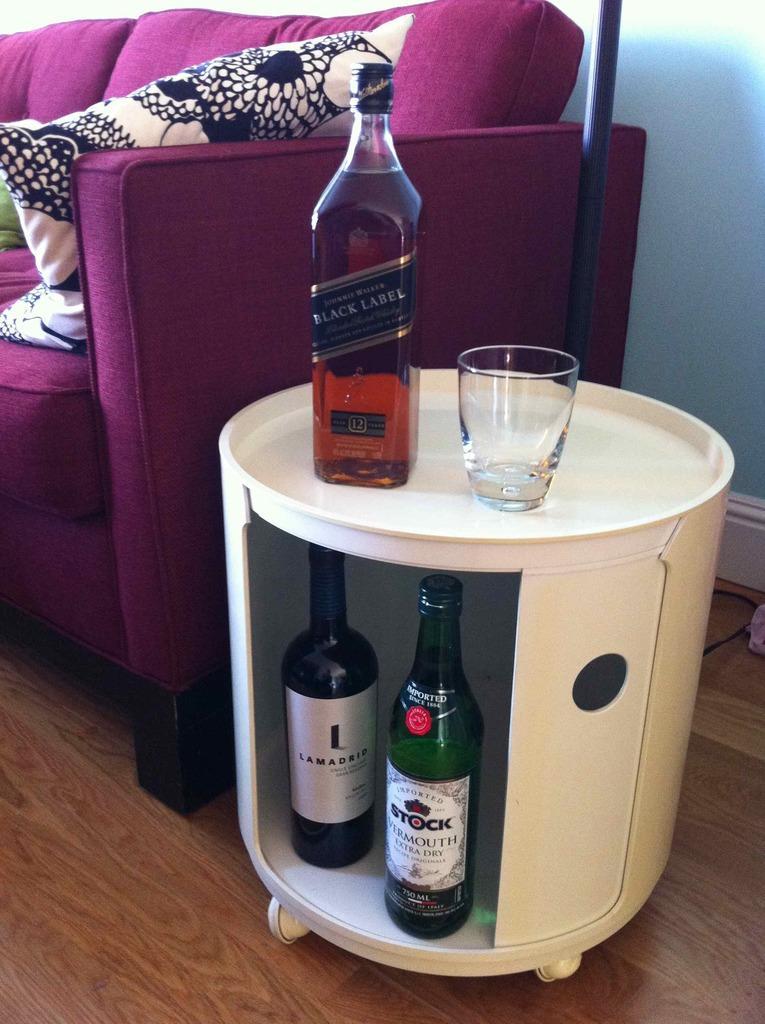Please provide a concise description of this image. In this image there is a group of wine bottles and glass in a table with 2 wheels and there is a couch , pillow, wall. 